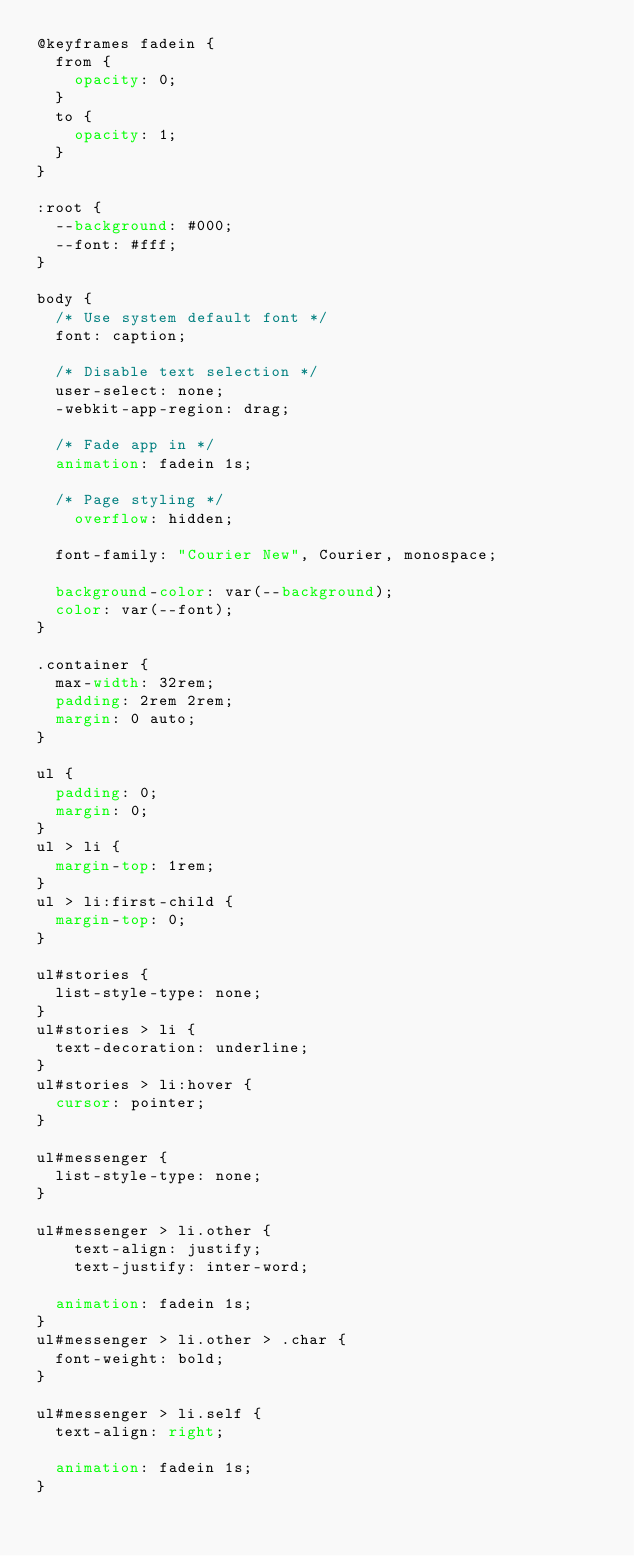<code> <loc_0><loc_0><loc_500><loc_500><_CSS_>@keyframes fadein {
	from {
		opacity: 0;
	}
	to {
		opacity: 1;
	}
}

:root {
	--background: #000;
	--font: #fff;
}

body {
	/* Use system default font */
	font: caption;
	
	/* Disable text selection */
	user-select: none;
	-webkit-app-region: drag;
	
	/* Fade app in */
	animation: fadein 1s;
	
	/* Page styling */
    overflow: hidden;
	
	font-family: "Courier New", Courier, monospace;
	
	background-color: var(--background);
	color: var(--font);
}

.container {
	max-width: 32rem;
	padding: 2rem 2rem;
	margin: 0 auto;
}

ul {
	padding: 0;
	margin: 0;
}
ul > li {
	margin-top: 1rem;
}
ul > li:first-child {
	margin-top: 0;
}

ul#stories {
	list-style-type: none;
}
ul#stories > li {
	text-decoration: underline;
}
ul#stories > li:hover {
	cursor: pointer;
}

ul#messenger {
	list-style-type: none;
}

ul#messenger > li.other {
    text-align: justify;
    text-justify: inter-word;
	
	animation: fadein 1s;
}
ul#messenger > li.other > .char {
	font-weight: bold;
}

ul#messenger > li.self {
	text-align: right;
	
	animation: fadein 1s;
}</code> 